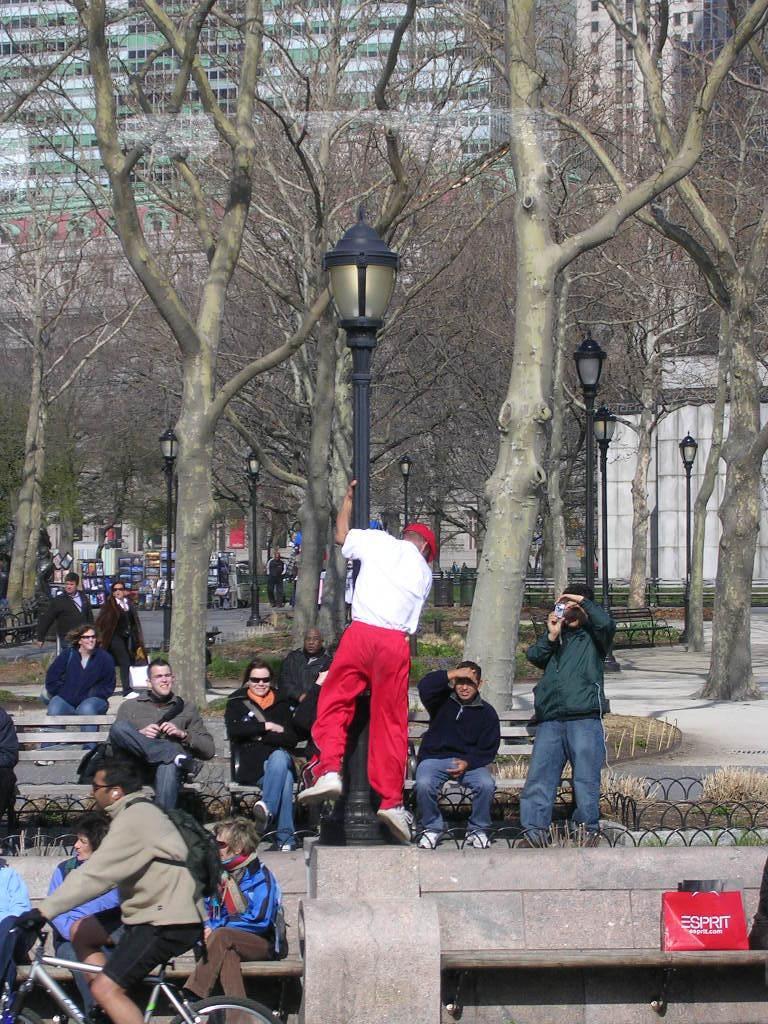How would you summarize this image in a sentence or two? The picture is taken on a road. On the left bottom a person is riding bicycle. He is carrying a bag. On the bench there are few people sitting on it beside the road. A person is holding a street lamp. In the background there are trees,buildings, and few other things. 